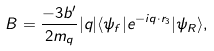<formula> <loc_0><loc_0><loc_500><loc_500>B = \frac { - 3 b ^ { \prime } } { 2 m _ { q } } | { q } | \langle \psi _ { f } | e ^ { - i { q } \cdot { r } _ { 3 } } | \psi _ { R } \rangle ,</formula> 